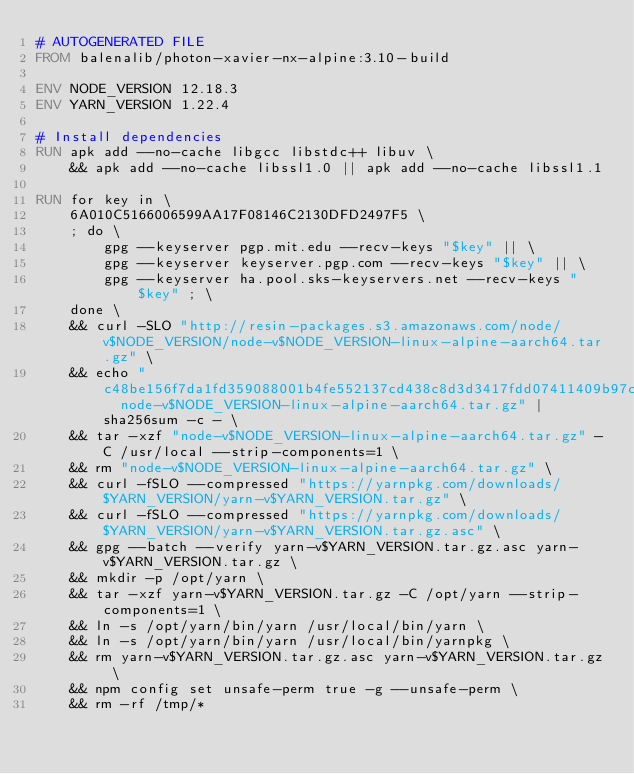<code> <loc_0><loc_0><loc_500><loc_500><_Dockerfile_># AUTOGENERATED FILE
FROM balenalib/photon-xavier-nx-alpine:3.10-build

ENV NODE_VERSION 12.18.3
ENV YARN_VERSION 1.22.4

# Install dependencies
RUN apk add --no-cache libgcc libstdc++ libuv \
	&& apk add --no-cache libssl1.0 || apk add --no-cache libssl1.1

RUN for key in \
	6A010C5166006599AA17F08146C2130DFD2497F5 \
	; do \
		gpg --keyserver pgp.mit.edu --recv-keys "$key" || \
		gpg --keyserver keyserver.pgp.com --recv-keys "$key" || \
		gpg --keyserver ha.pool.sks-keyservers.net --recv-keys "$key" ; \
	done \
	&& curl -SLO "http://resin-packages.s3.amazonaws.com/node/v$NODE_VERSION/node-v$NODE_VERSION-linux-alpine-aarch64.tar.gz" \
	&& echo "c48be156f7da1fd359088001b4fe552137cd438c8d3d3417fdd07411409b97c1  node-v$NODE_VERSION-linux-alpine-aarch64.tar.gz" | sha256sum -c - \
	&& tar -xzf "node-v$NODE_VERSION-linux-alpine-aarch64.tar.gz" -C /usr/local --strip-components=1 \
	&& rm "node-v$NODE_VERSION-linux-alpine-aarch64.tar.gz" \
	&& curl -fSLO --compressed "https://yarnpkg.com/downloads/$YARN_VERSION/yarn-v$YARN_VERSION.tar.gz" \
	&& curl -fSLO --compressed "https://yarnpkg.com/downloads/$YARN_VERSION/yarn-v$YARN_VERSION.tar.gz.asc" \
	&& gpg --batch --verify yarn-v$YARN_VERSION.tar.gz.asc yarn-v$YARN_VERSION.tar.gz \
	&& mkdir -p /opt/yarn \
	&& tar -xzf yarn-v$YARN_VERSION.tar.gz -C /opt/yarn --strip-components=1 \
	&& ln -s /opt/yarn/bin/yarn /usr/local/bin/yarn \
	&& ln -s /opt/yarn/bin/yarn /usr/local/bin/yarnpkg \
	&& rm yarn-v$YARN_VERSION.tar.gz.asc yarn-v$YARN_VERSION.tar.gz \
	&& npm config set unsafe-perm true -g --unsafe-perm \
	&& rm -rf /tmp/*
</code> 